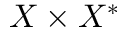<formula> <loc_0><loc_0><loc_500><loc_500>X \times X ^ { * }</formula> 